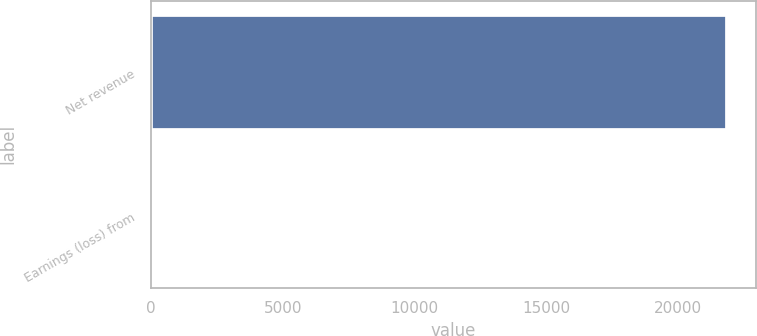<chart> <loc_0><loc_0><loc_500><loc_500><bar_chart><fcel>Net revenue<fcel>Earnings (loss) from<nl><fcel>21869<fcel>1.7<nl></chart> 